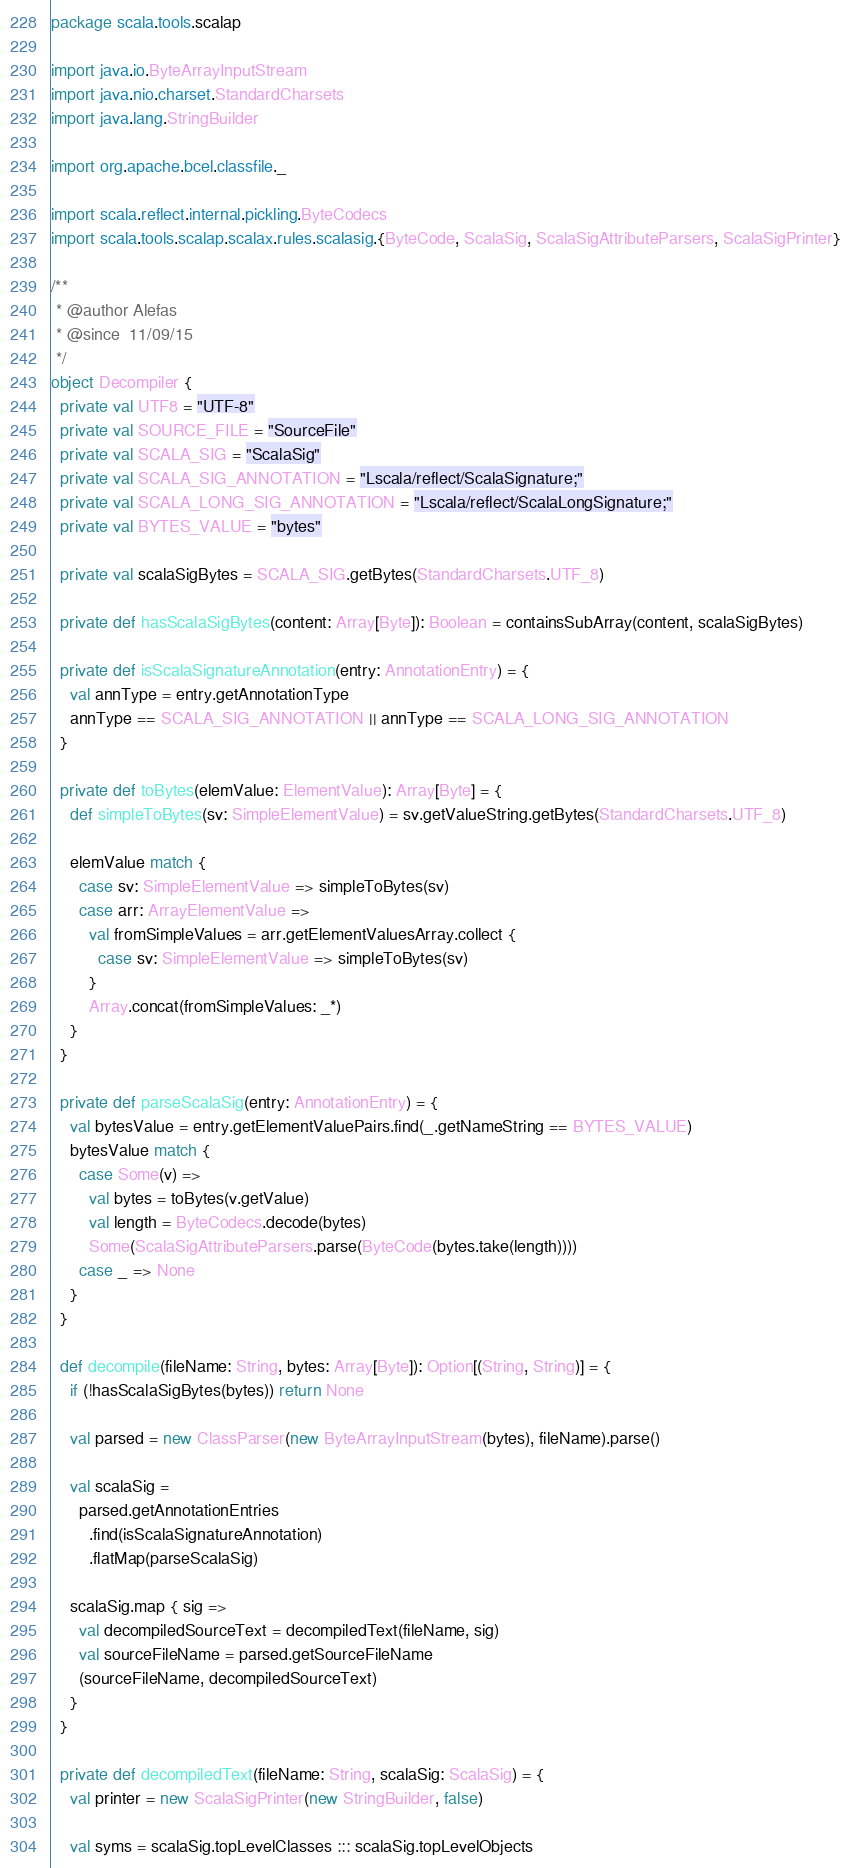Convert code to text. <code><loc_0><loc_0><loc_500><loc_500><_Scala_>package scala.tools.scalap

import java.io.ByteArrayInputStream
import java.nio.charset.StandardCharsets
import java.lang.StringBuilder

import org.apache.bcel.classfile._

import scala.reflect.internal.pickling.ByteCodecs
import scala.tools.scalap.scalax.rules.scalasig.{ByteCode, ScalaSig, ScalaSigAttributeParsers, ScalaSigPrinter}

/**
 * @author Alefas
 * @since  11/09/15
 */
object Decompiler {
  private val UTF8 = "UTF-8"
  private val SOURCE_FILE = "SourceFile"
  private val SCALA_SIG = "ScalaSig"
  private val SCALA_SIG_ANNOTATION = "Lscala/reflect/ScalaSignature;"
  private val SCALA_LONG_SIG_ANNOTATION = "Lscala/reflect/ScalaLongSignature;"
  private val BYTES_VALUE = "bytes"

  private val scalaSigBytes = SCALA_SIG.getBytes(StandardCharsets.UTF_8)

  private def hasScalaSigBytes(content: Array[Byte]): Boolean = containsSubArray(content, scalaSigBytes)

  private def isScalaSignatureAnnotation(entry: AnnotationEntry) = {
    val annType = entry.getAnnotationType
    annType == SCALA_SIG_ANNOTATION || annType == SCALA_LONG_SIG_ANNOTATION
  }

  private def toBytes(elemValue: ElementValue): Array[Byte] = {
    def simpleToBytes(sv: SimpleElementValue) = sv.getValueString.getBytes(StandardCharsets.UTF_8)

    elemValue match {
      case sv: SimpleElementValue => simpleToBytes(sv)
      case arr: ArrayElementValue =>
        val fromSimpleValues = arr.getElementValuesArray.collect {
          case sv: SimpleElementValue => simpleToBytes(sv)
        }
        Array.concat(fromSimpleValues: _*)
    }
  }

  private def parseScalaSig(entry: AnnotationEntry) = {
    val bytesValue = entry.getElementValuePairs.find(_.getNameString == BYTES_VALUE)
    bytesValue match {
      case Some(v) =>
        val bytes = toBytes(v.getValue)
        val length = ByteCodecs.decode(bytes)
        Some(ScalaSigAttributeParsers.parse(ByteCode(bytes.take(length))))
      case _ => None
    }
  }

  def decompile(fileName: String, bytes: Array[Byte]): Option[(String, String)] = {
    if (!hasScalaSigBytes(bytes)) return None

    val parsed = new ClassParser(new ByteArrayInputStream(bytes), fileName).parse()

    val scalaSig =
      parsed.getAnnotationEntries
        .find(isScalaSignatureAnnotation)
        .flatMap(parseScalaSig)

    scalaSig.map { sig =>
      val decompiledSourceText = decompiledText(fileName, sig)
      val sourceFileName = parsed.getSourceFileName
      (sourceFileName, decompiledSourceText)
    }
  }

  private def decompiledText(fileName: String, scalaSig: ScalaSig) = {
    val printer = new ScalaSigPrinter(new StringBuilder, false)

    val syms = scalaSig.topLevelClasses ::: scalaSig.topLevelObjects</code> 